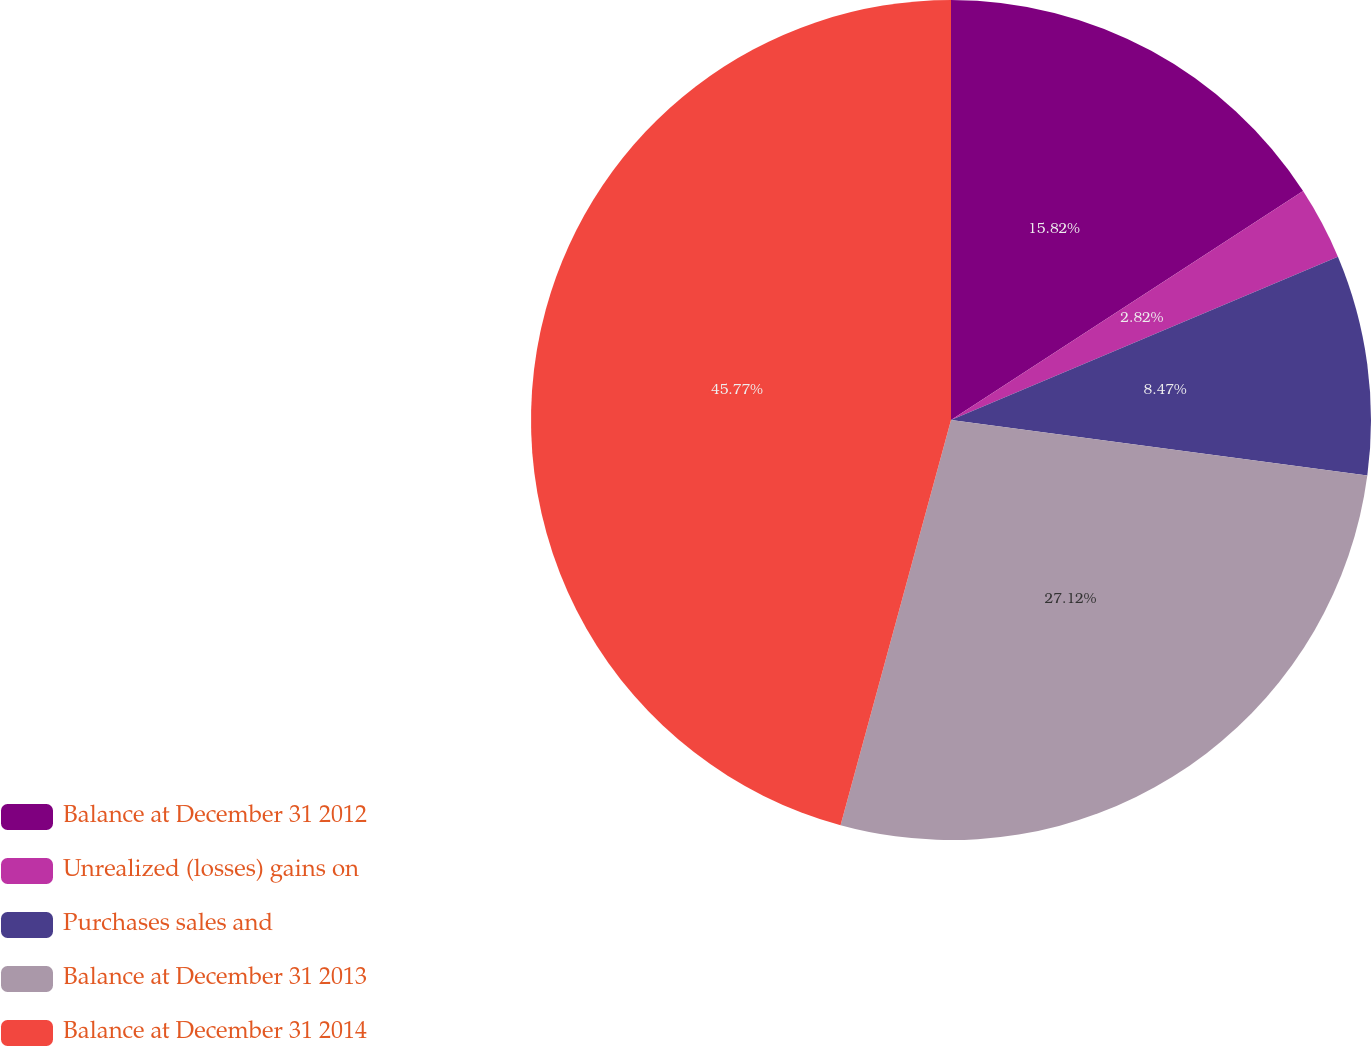Convert chart. <chart><loc_0><loc_0><loc_500><loc_500><pie_chart><fcel>Balance at December 31 2012<fcel>Unrealized (losses) gains on<fcel>Purchases sales and<fcel>Balance at December 31 2013<fcel>Balance at December 31 2014<nl><fcel>15.82%<fcel>2.82%<fcel>8.47%<fcel>27.12%<fcel>45.76%<nl></chart> 